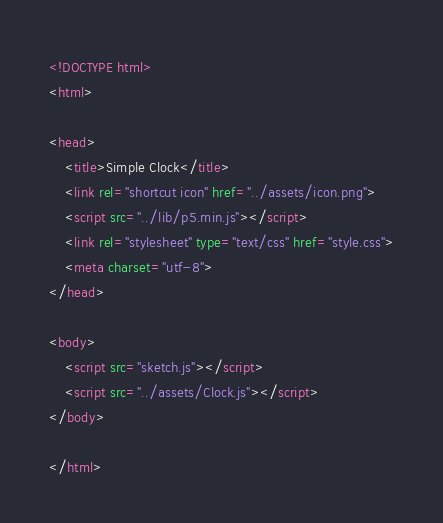Convert code to text. <code><loc_0><loc_0><loc_500><loc_500><_HTML_><!DOCTYPE html>
<html>

<head>
    <title>Simple Clock</title>
    <link rel="shortcut icon" href="../assets/icon.png">
    <script src="../lib/p5.min.js"></script>
    <link rel="stylesheet" type="text/css" href="style.css">
    <meta charset="utf-8">
</head>

<body>
    <script src="sketch.js"></script>
    <script src="../assets/Clock.js"></script>
</body>

</html></code> 